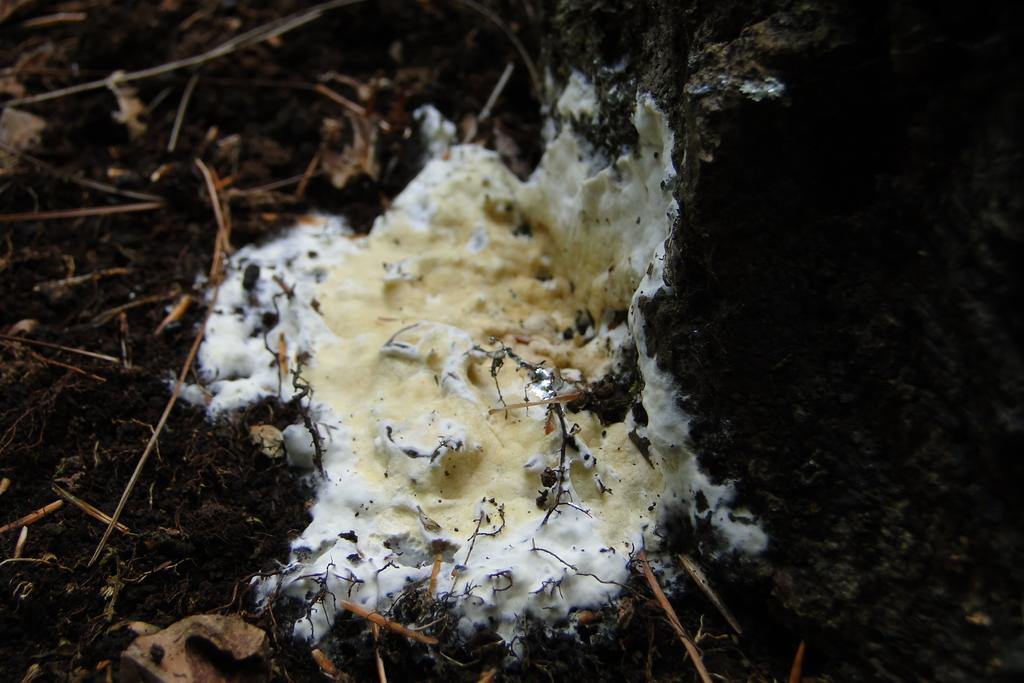What type of living organism can be seen in the image? There is fungus in the image. What non-living object is present in the image? There is a rock in the image. What type of vegetation is visible in the image? There is grass in the image. How does the fungus breathe in the image? Fungi do not breathe like animals; they absorb nutrients through their cell walls. In the image, there is no indication of the fungus breathing or absorbing nutrients. 